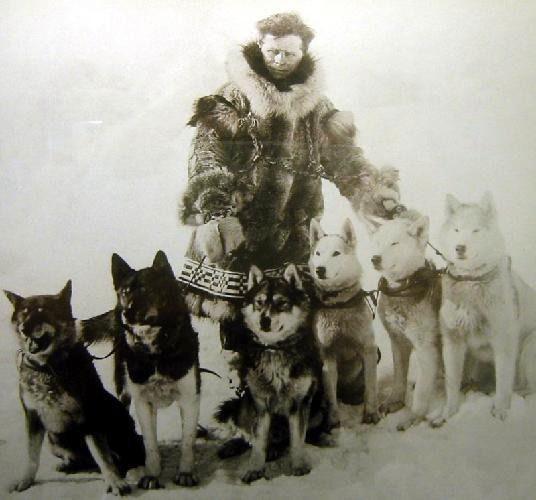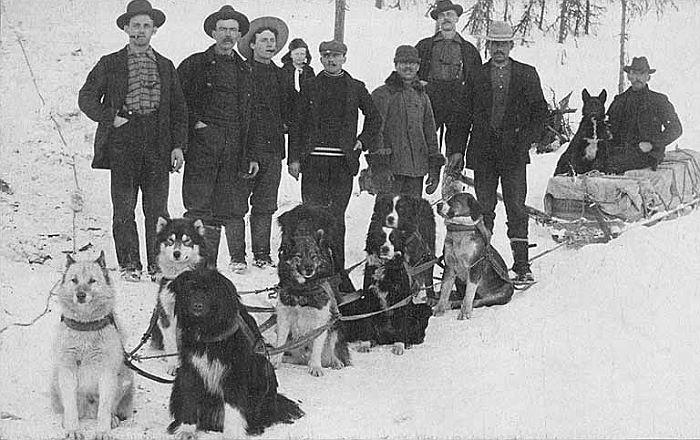The first image is the image on the left, the second image is the image on the right. Assess this claim about the two images: "A person bundled in fur for warm is posing behind one sled dog in the right image.". Correct or not? Answer yes or no. No. 